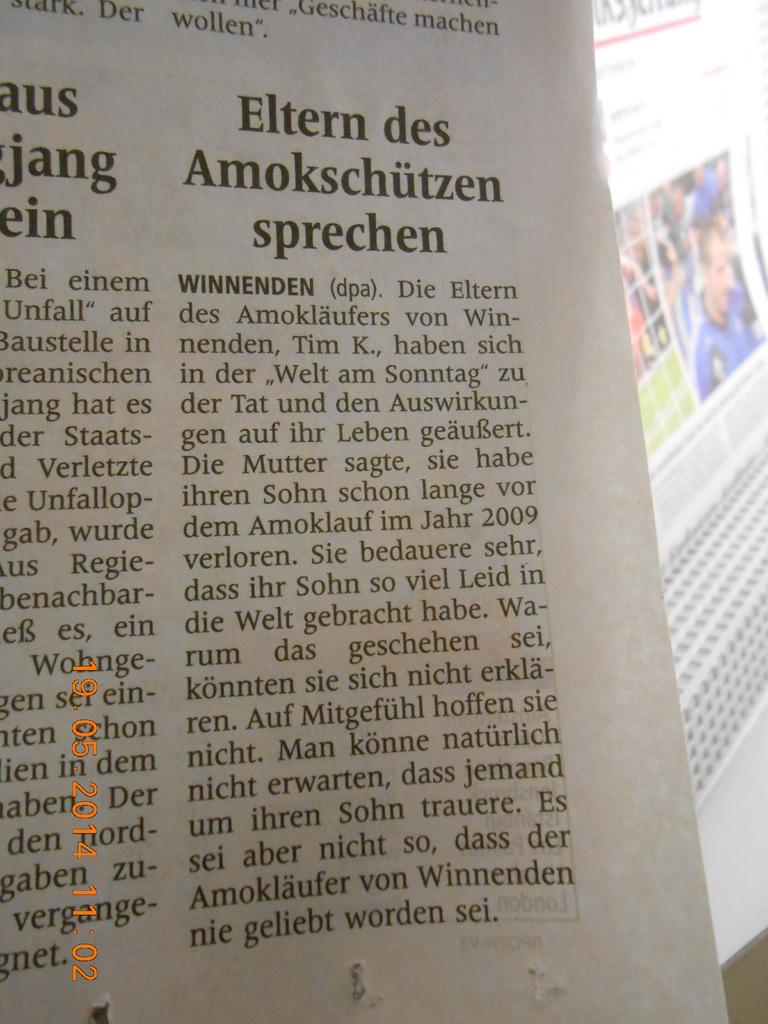Provide a one-sentence caption for the provided image. A newspaper headline reads "Eltern des Smokschutzen sprechen". 